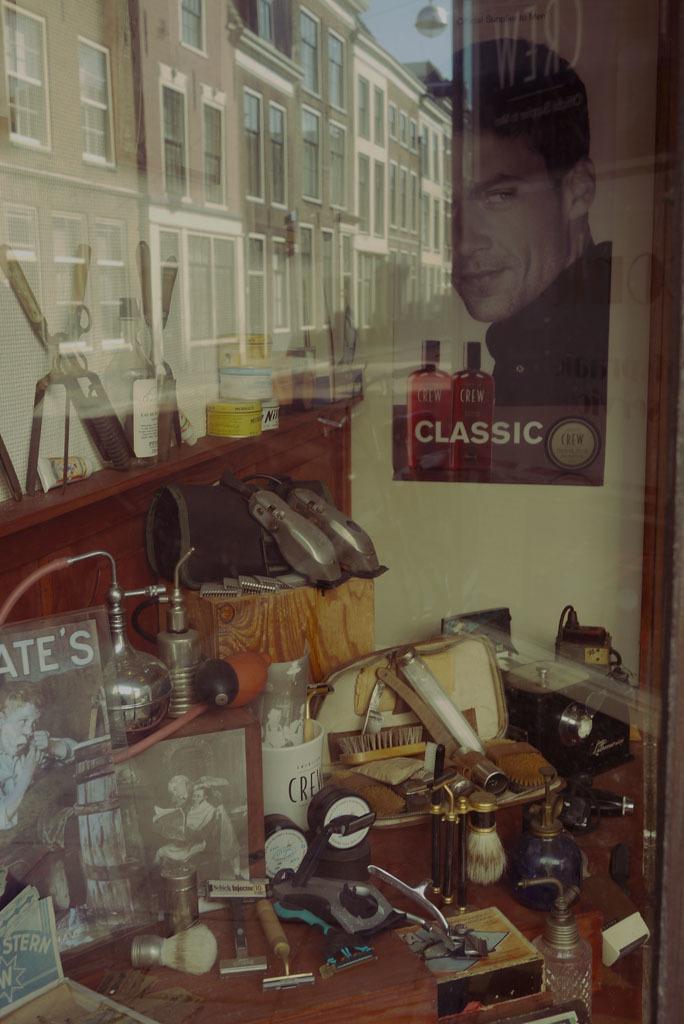Could you give a brief overview of what you see in this image? At the bottom of the image there is a table and there are many things placed on the table some of them are bottles, pots, brushes, screws and some papers. In the background there is a wall and a poster on the wall. We can also the reflection of a building on the glass. 